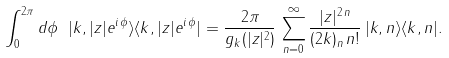Convert formula to latex. <formula><loc_0><loc_0><loc_500><loc_500>\int _ { 0 } ^ { 2 \pi } d \phi \ | k , | z | e ^ { i \, \phi } \rangle \langle k , | z | e ^ { i \, \phi } | = \frac { 2 \pi } { g _ { k } ( | z | ^ { 2 } ) } \, \sum _ { n = 0 } ^ { \infty } \frac { | z | ^ { 2 \, n } } { ( 2 k ) _ { n } \, n ! } \, | k , n \rangle \langle k , n | .</formula> 